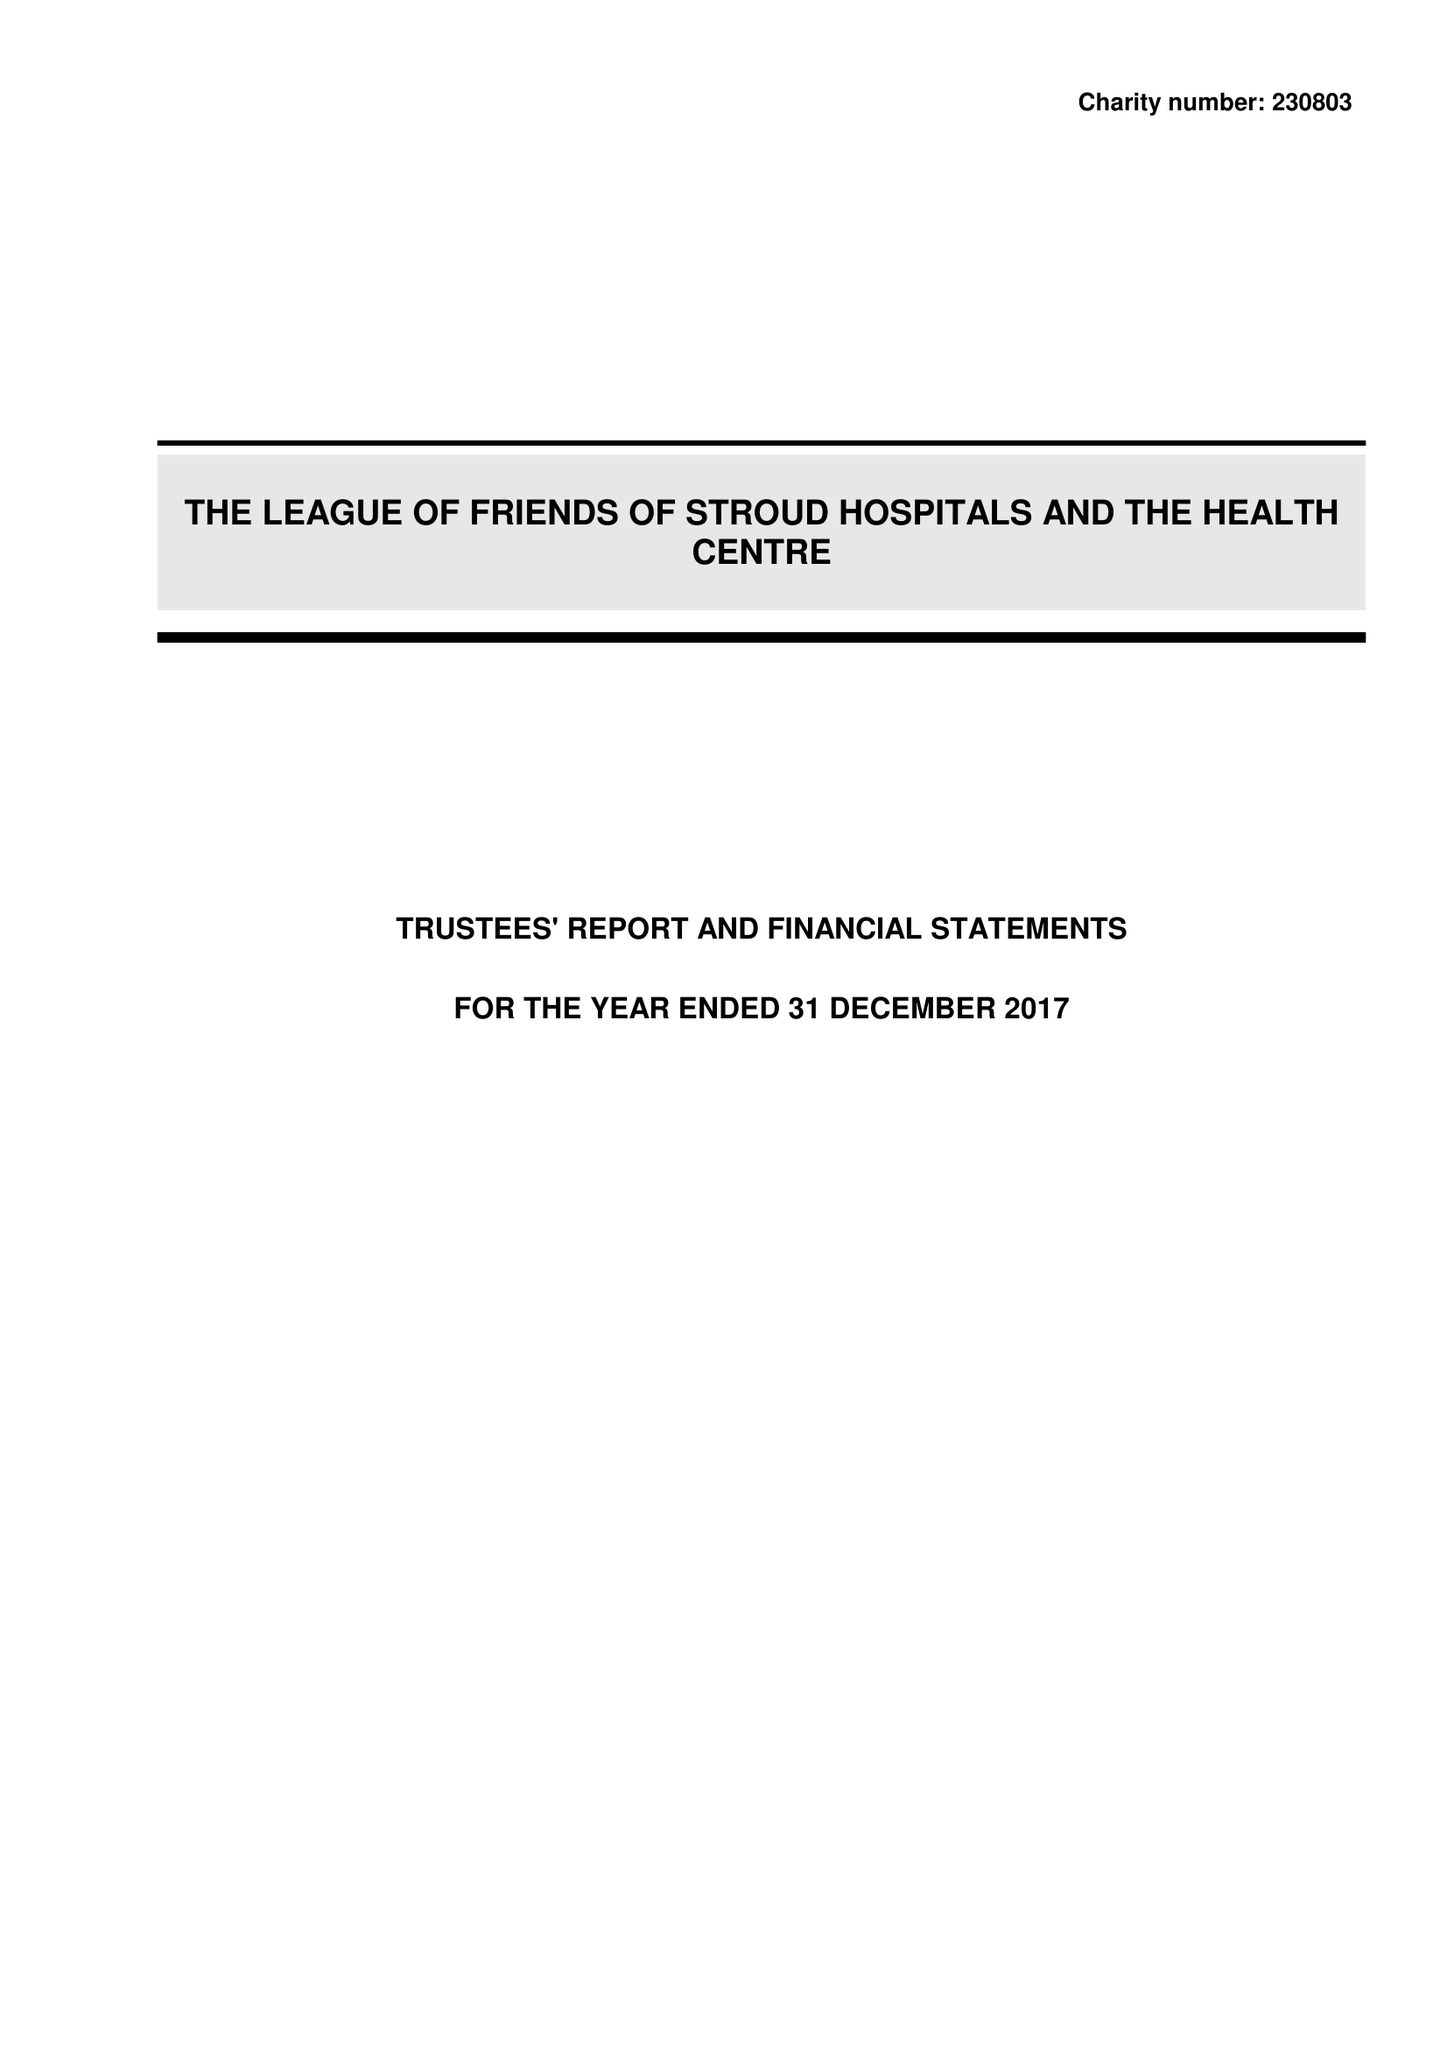What is the value for the charity_number?
Answer the question using a single word or phrase. 230803 